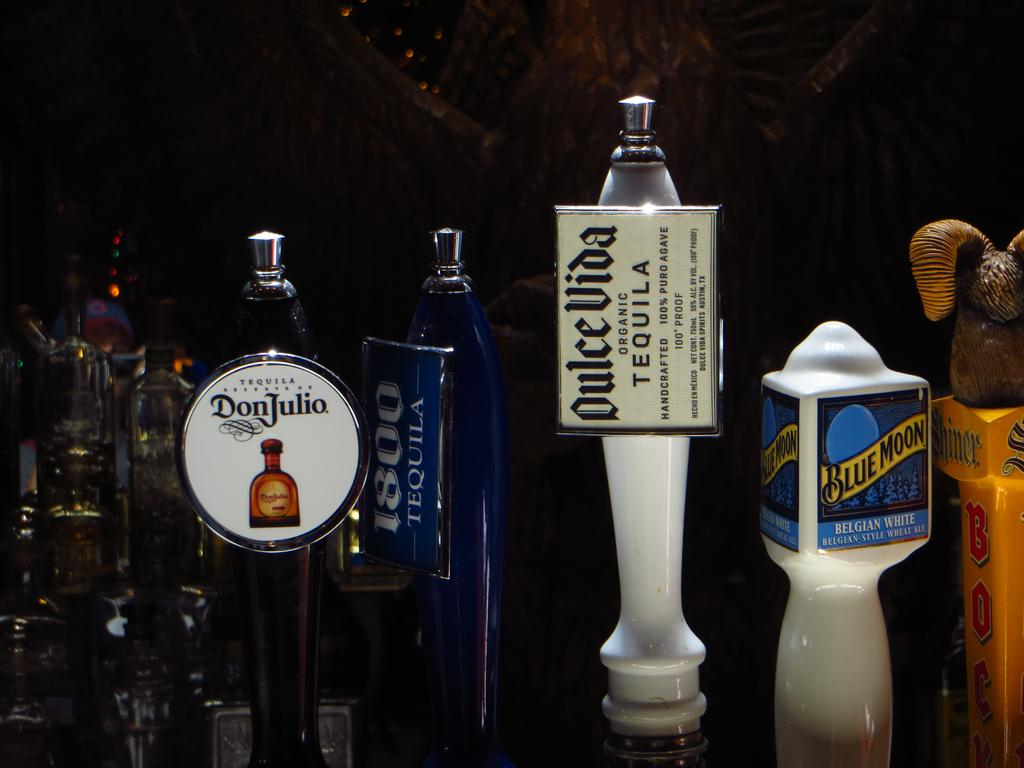<image>
Create a compact narrative representing the image presented. Bar taps with many varieties including one named Blue Moon 